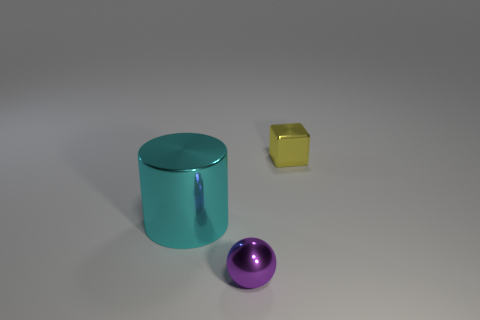Is there anything else that is the same size as the cylinder?
Ensure brevity in your answer.  No. What number of objects are small purple metal spheres or yellow metal objects?
Make the answer very short. 2. Is the shape of the big metallic object the same as the small yellow metal thing?
Ensure brevity in your answer.  No. What material is the large cyan cylinder?
Ensure brevity in your answer.  Metal. What number of objects are both on the left side of the tiny sphere and to the right of the cyan metallic cylinder?
Make the answer very short. 0. Does the cyan metallic cylinder have the same size as the cube?
Your answer should be compact. No. There is a shiny object that is to the right of the purple object; does it have the same size as the cyan metal object?
Your response must be concise. No. There is a thing behind the big cylinder; what is its color?
Give a very brief answer. Yellow. How many small objects are there?
Your answer should be compact. 2. What is the shape of the purple thing that is the same material as the small yellow block?
Your answer should be very brief. Sphere. 